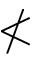Convert formula to latex. <formula><loc_0><loc_0><loc_500><loc_500>\nless</formula> 